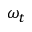Convert formula to latex. <formula><loc_0><loc_0><loc_500><loc_500>\omega _ { t }</formula> 